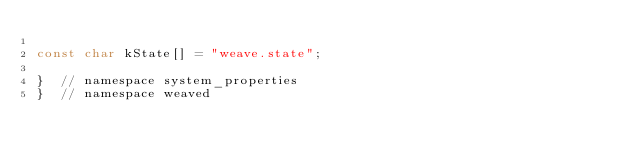<code> <loc_0><loc_0><loc_500><loc_500><_C++_>
const char kState[] = "weave.state";

}  // namespace system_properties
}  // namespace weaved
</code> 